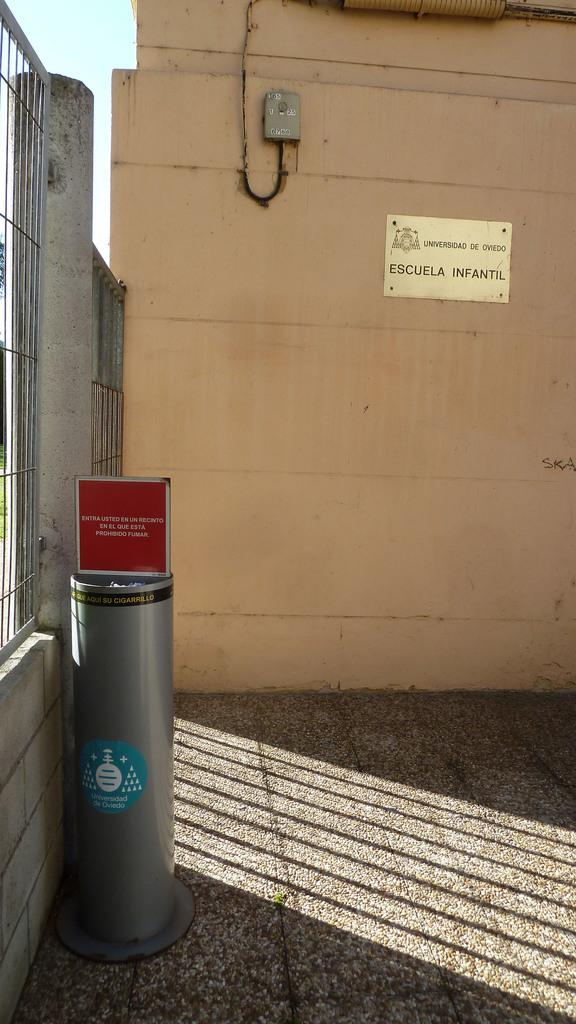<image>
Provide a brief description of the given image. A silver trash can reading universidad on a sticker 